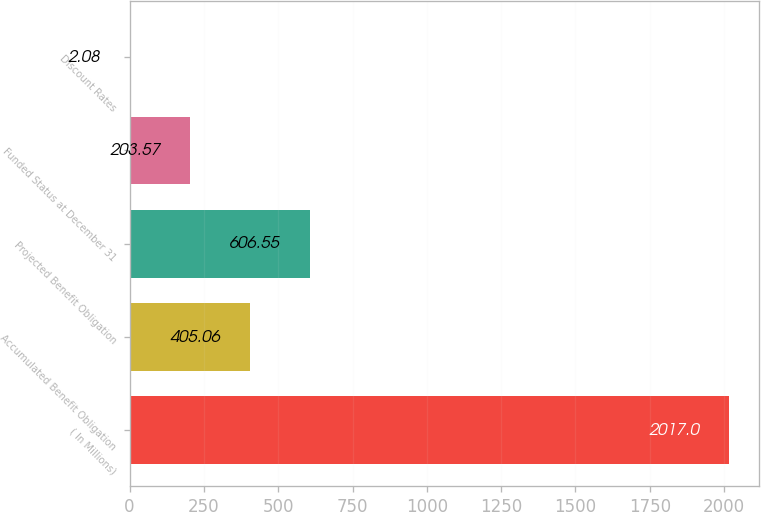Convert chart. <chart><loc_0><loc_0><loc_500><loc_500><bar_chart><fcel>( In Millions)<fcel>Accumulated Benefit Obligation<fcel>Projected Benefit Obligation<fcel>Funded Status at December 31<fcel>Discount Rates<nl><fcel>2017<fcel>405.06<fcel>606.55<fcel>203.57<fcel>2.08<nl></chart> 